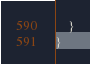Convert code to text. <code><loc_0><loc_0><loc_500><loc_500><_C#_>    }
}
</code> 